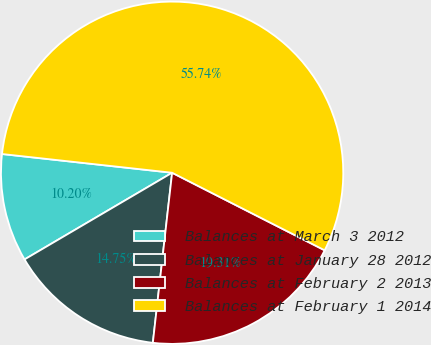Convert chart. <chart><loc_0><loc_0><loc_500><loc_500><pie_chart><fcel>Balances at March 3 2012<fcel>Balances at January 28 2012<fcel>Balances at February 2 2013<fcel>Balances at February 1 2014<nl><fcel>10.2%<fcel>14.75%<fcel>19.31%<fcel>55.74%<nl></chart> 